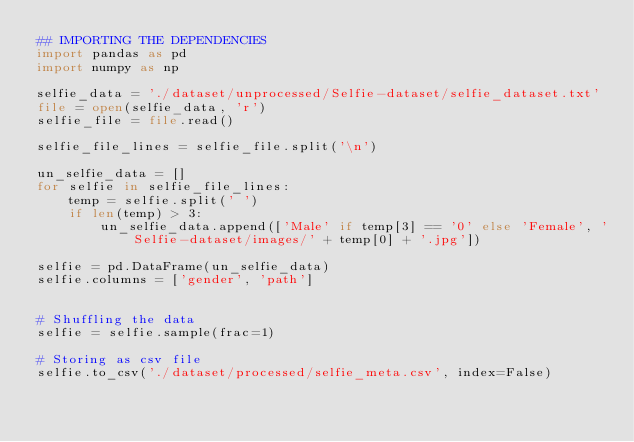Convert code to text. <code><loc_0><loc_0><loc_500><loc_500><_Python_>## IMPORTING THE DEPENDENCIES
import pandas as pd
import numpy as np

selfie_data = './dataset/unprocessed/Selfie-dataset/selfie_dataset.txt'
file = open(selfie_data, 'r')
selfie_file = file.read()

selfie_file_lines = selfie_file.split('\n')

un_selfie_data = []
for selfie in selfie_file_lines:
    temp = selfie.split(' ')
    if len(temp) > 3:
        un_selfie_data.append(['Male' if temp[3] == '0' else 'Female', 'Selfie-dataset/images/' + temp[0] + '.jpg']) 

selfie = pd.DataFrame(un_selfie_data)
selfie.columns = ['gender', 'path']


# Shuffling the data
selfie = selfie.sample(frac=1)

# Storing as csv file
selfie.to_csv('./dataset/processed/selfie_meta.csv', index=False)</code> 